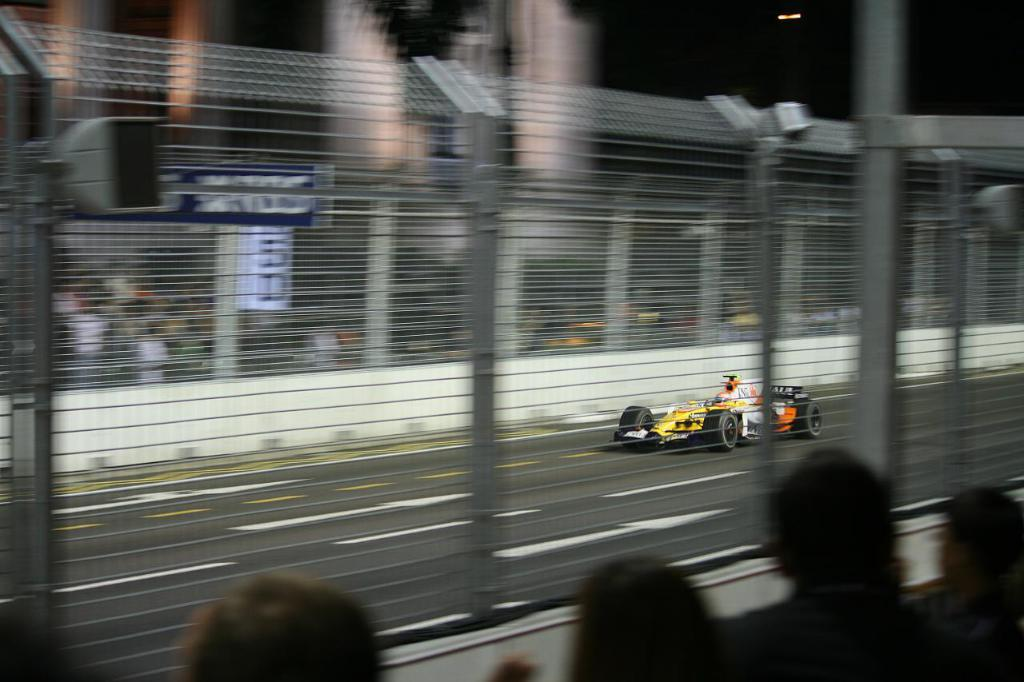What can be seen in the foreground of the image? There are people and net fencing in the foreground of the image. Can you describe the people in the foreground? The people in the foreground are likely engaged in some activity, as they are near the net fencing. What is visible in the background of the image? There are other people and a sports car in the background of the image. How many people are present in the image? There are people in both the foreground and background, so there are multiple people present in the image. Where is the faucet located in the image? There is no faucet present in the image. What type of trousers are the people wearing in the image? The provided facts do not mention the type of clothing the people are wearing, so we cannot determine the type of trousers they are wearing. 